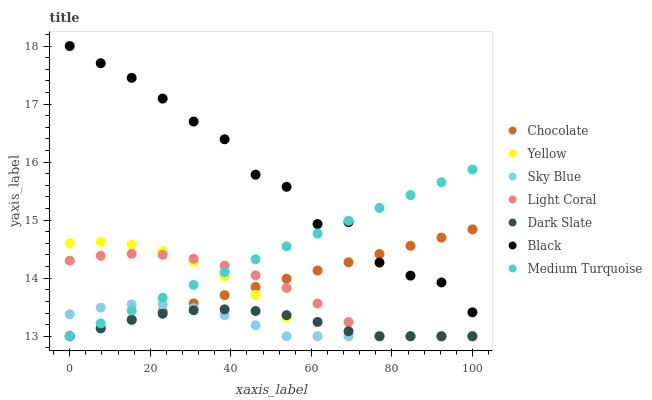Does Sky Blue have the minimum area under the curve?
Answer yes or no. Yes. Does Black have the maximum area under the curve?
Answer yes or no. Yes. Does Chocolate have the minimum area under the curve?
Answer yes or no. No. Does Chocolate have the maximum area under the curve?
Answer yes or no. No. Is Chocolate the smoothest?
Answer yes or no. Yes. Is Black the roughest?
Answer yes or no. Yes. Is Light Coral the smoothest?
Answer yes or no. No. Is Light Coral the roughest?
Answer yes or no. No. Does Yellow have the lowest value?
Answer yes or no. Yes. Does Black have the lowest value?
Answer yes or no. No. Does Black have the highest value?
Answer yes or no. Yes. Does Chocolate have the highest value?
Answer yes or no. No. Is Yellow less than Black?
Answer yes or no. Yes. Is Black greater than Sky Blue?
Answer yes or no. Yes. Does Light Coral intersect Dark Slate?
Answer yes or no. Yes. Is Light Coral less than Dark Slate?
Answer yes or no. No. Is Light Coral greater than Dark Slate?
Answer yes or no. No. Does Yellow intersect Black?
Answer yes or no. No. 